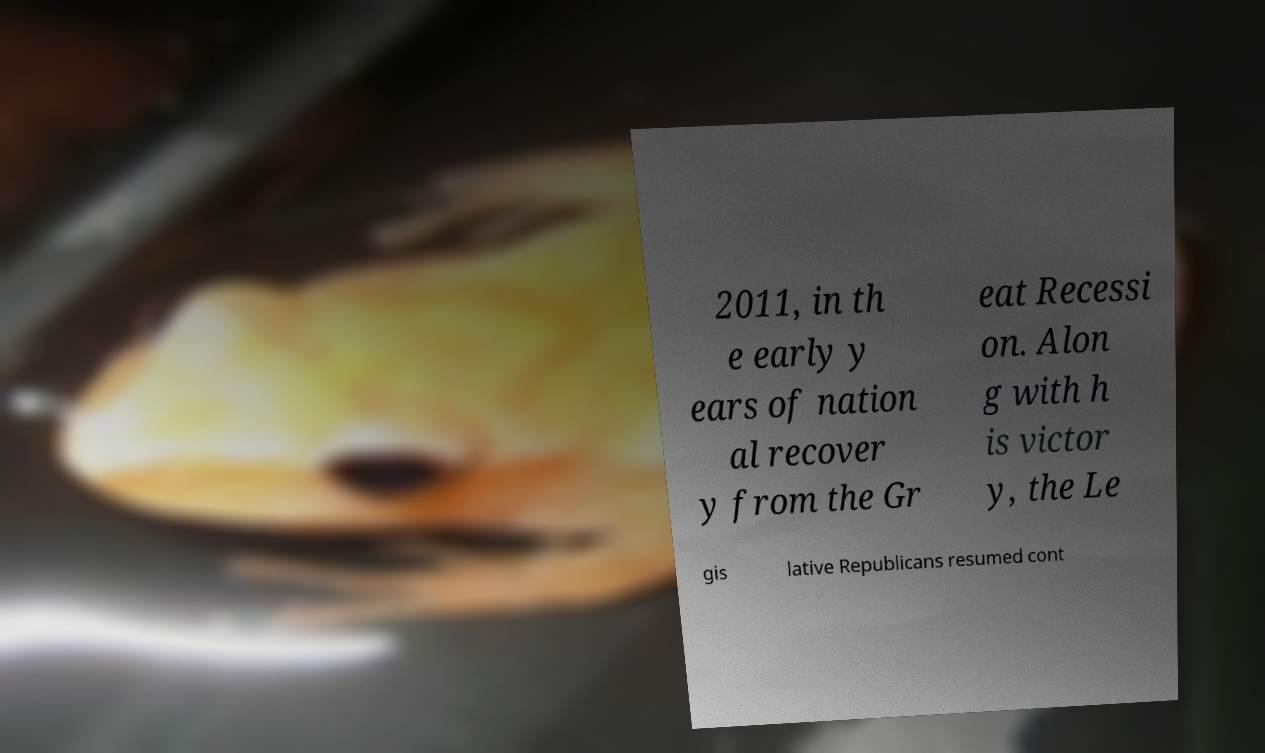Could you assist in decoding the text presented in this image and type it out clearly? 2011, in th e early y ears of nation al recover y from the Gr eat Recessi on. Alon g with h is victor y, the Le gis lative Republicans resumed cont 